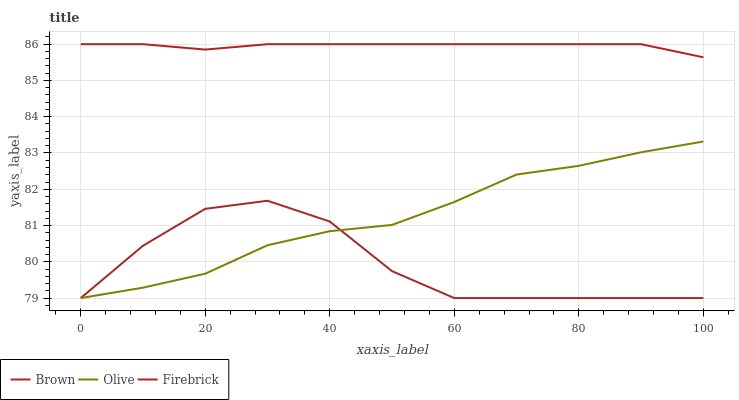Does Brown have the minimum area under the curve?
Answer yes or no. Yes. Does Firebrick have the maximum area under the curve?
Answer yes or no. Yes. Does Firebrick have the minimum area under the curve?
Answer yes or no. No. Does Brown have the maximum area under the curve?
Answer yes or no. No. Is Firebrick the smoothest?
Answer yes or no. Yes. Is Brown the roughest?
Answer yes or no. Yes. Is Brown the smoothest?
Answer yes or no. No. Is Firebrick the roughest?
Answer yes or no. No. Does Olive have the lowest value?
Answer yes or no. Yes. Does Firebrick have the lowest value?
Answer yes or no. No. Does Firebrick have the highest value?
Answer yes or no. Yes. Does Brown have the highest value?
Answer yes or no. No. Is Olive less than Firebrick?
Answer yes or no. Yes. Is Firebrick greater than Olive?
Answer yes or no. Yes. Does Olive intersect Brown?
Answer yes or no. Yes. Is Olive less than Brown?
Answer yes or no. No. Is Olive greater than Brown?
Answer yes or no. No. Does Olive intersect Firebrick?
Answer yes or no. No. 